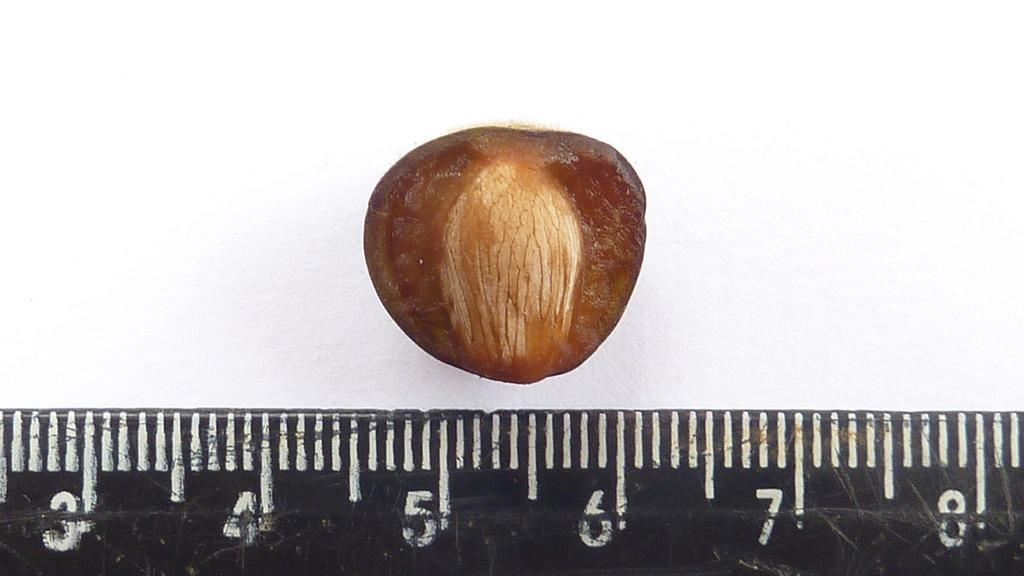<image>
Provide a brief description of the given image. The nut shown measures from 4.5 to 6 centimetres. 